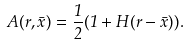<formula> <loc_0><loc_0><loc_500><loc_500>A ( r , \bar { x } ) = \frac { 1 } { 2 } ( 1 + H ( r - \bar { x } ) ) .</formula> 